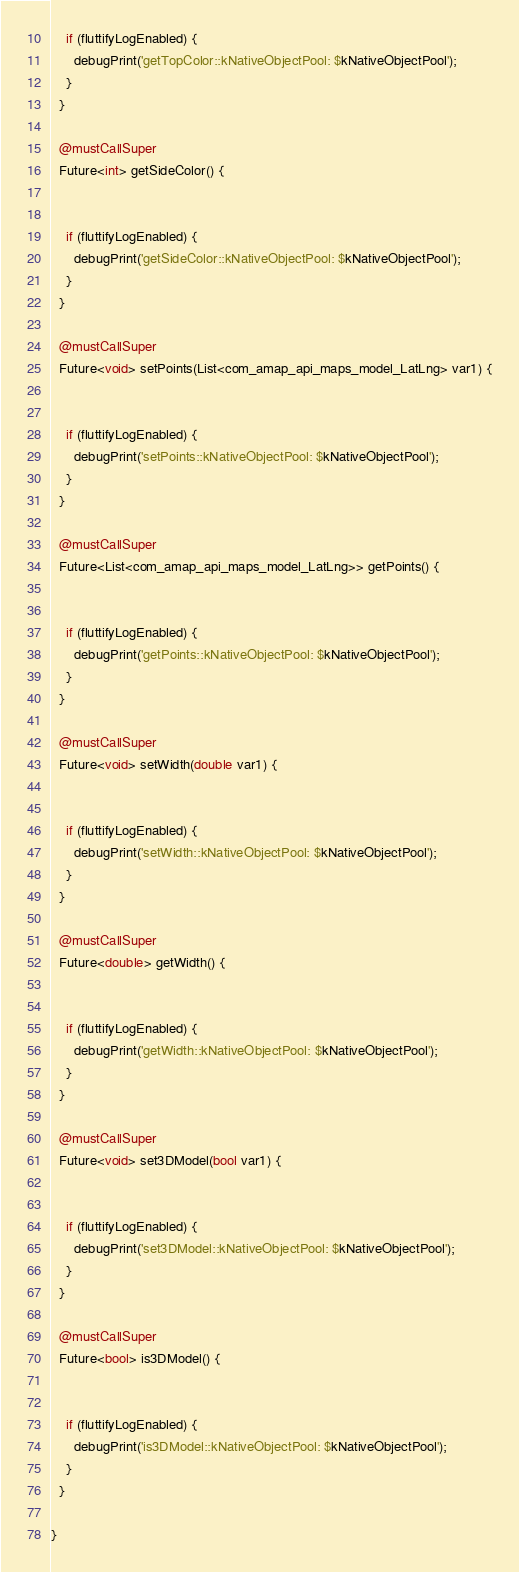<code> <loc_0><loc_0><loc_500><loc_500><_Dart_>    if (fluttifyLogEnabled) {
      debugPrint('getTopColor::kNativeObjectPool: $kNativeObjectPool');
    }
  }
  
  @mustCallSuper
  Future<int> getSideColor() {
  
  
    if (fluttifyLogEnabled) {
      debugPrint('getSideColor::kNativeObjectPool: $kNativeObjectPool');
    }
  }
  
  @mustCallSuper
  Future<void> setPoints(List<com_amap_api_maps_model_LatLng> var1) {
  
  
    if (fluttifyLogEnabled) {
      debugPrint('setPoints::kNativeObjectPool: $kNativeObjectPool');
    }
  }
  
  @mustCallSuper
  Future<List<com_amap_api_maps_model_LatLng>> getPoints() {
  
  
    if (fluttifyLogEnabled) {
      debugPrint('getPoints::kNativeObjectPool: $kNativeObjectPool');
    }
  }
  
  @mustCallSuper
  Future<void> setWidth(double var1) {
  
  
    if (fluttifyLogEnabled) {
      debugPrint('setWidth::kNativeObjectPool: $kNativeObjectPool');
    }
  }
  
  @mustCallSuper
  Future<double> getWidth() {
  
  
    if (fluttifyLogEnabled) {
      debugPrint('getWidth::kNativeObjectPool: $kNativeObjectPool');
    }
  }
  
  @mustCallSuper
  Future<void> set3DModel(bool var1) {
  
  
    if (fluttifyLogEnabled) {
      debugPrint('set3DModel::kNativeObjectPool: $kNativeObjectPool');
    }
  }
  
  @mustCallSuper
  Future<bool> is3DModel() {
  
  
    if (fluttifyLogEnabled) {
      debugPrint('is3DModel::kNativeObjectPool: $kNativeObjectPool');
    }
  }
  
}</code> 